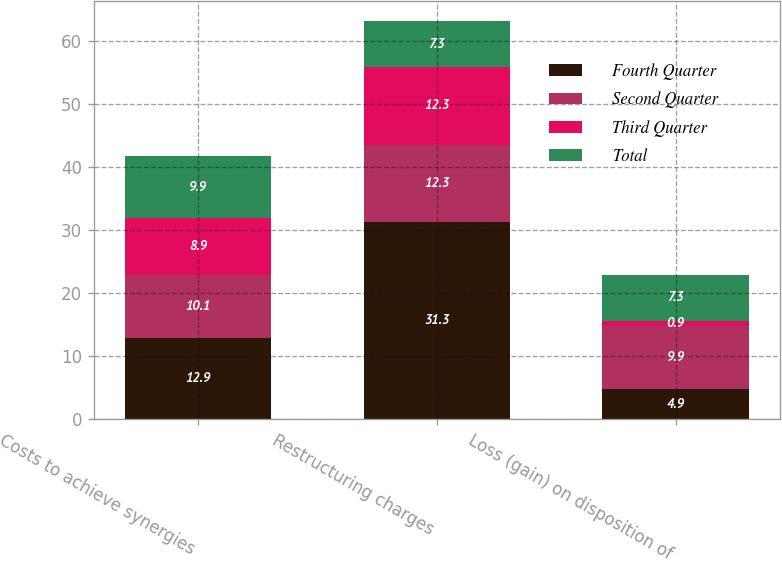<chart> <loc_0><loc_0><loc_500><loc_500><stacked_bar_chart><ecel><fcel>Costs to achieve synergies<fcel>Restructuring charges<fcel>Loss (gain) on disposition of<nl><fcel>Fourth Quarter<fcel>12.9<fcel>31.3<fcel>4.9<nl><fcel>Second Quarter<fcel>10.1<fcel>12.3<fcel>9.9<nl><fcel>Third Quarter<fcel>8.9<fcel>12.3<fcel>0.9<nl><fcel>Total<fcel>9.9<fcel>7.3<fcel>7.3<nl></chart> 